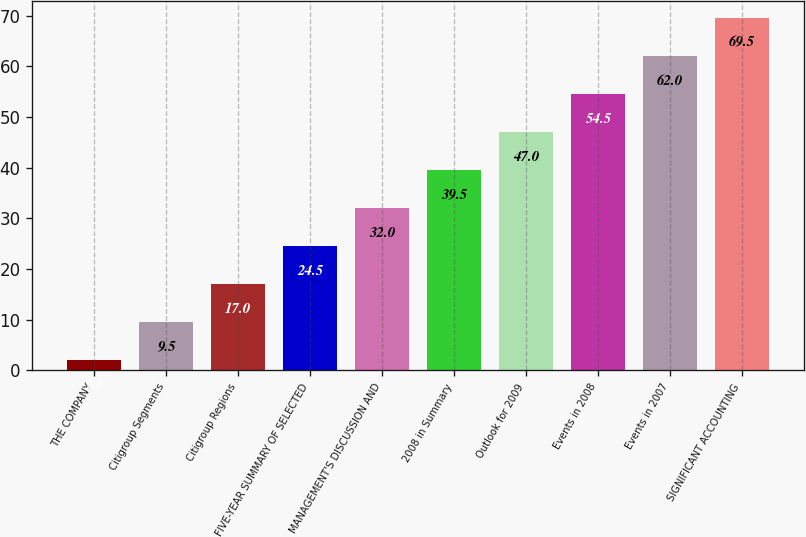<chart> <loc_0><loc_0><loc_500><loc_500><bar_chart><fcel>THE COMPANY<fcel>Citigroup Segments<fcel>Citigroup Regions<fcel>FIVE-YEAR SUMMARY OF SELECTED<fcel>MANAGEMENT'S DISCUSSION AND<fcel>2008 in Summary<fcel>Outlook for 2009<fcel>Events in 2008<fcel>Events in 2007<fcel>SIGNIFICANT ACCOUNTING<nl><fcel>2<fcel>9.5<fcel>17<fcel>24.5<fcel>32<fcel>39.5<fcel>47<fcel>54.5<fcel>62<fcel>69.5<nl></chart> 